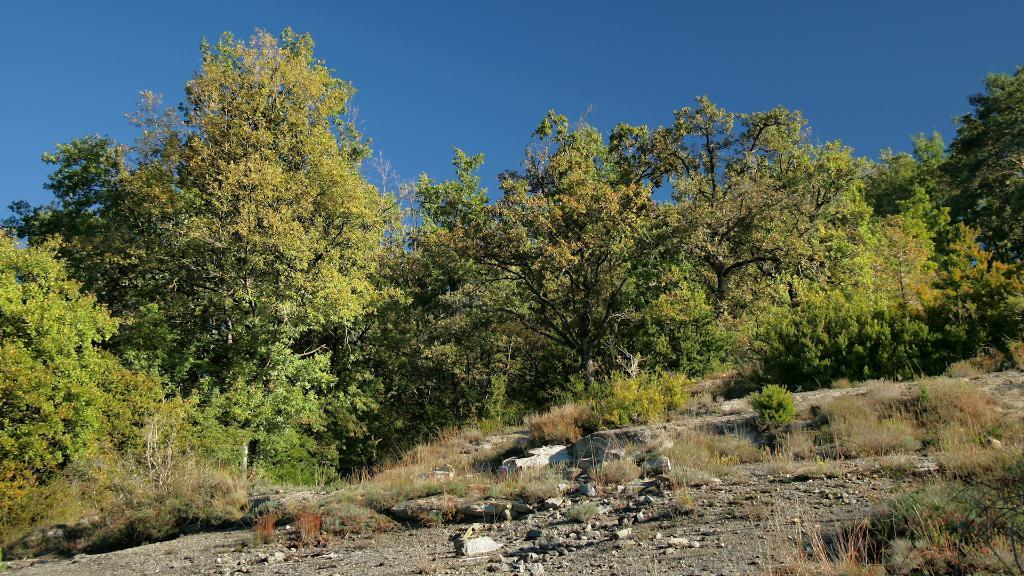What type of natural elements can be seen on the ground in the image? There are rocks on the ground in the image. What type of vegetation is visible in the background of the image? There are trees in the background of the image. What is the color of the sky in the image? The sky is blue in color in the image. Can you tell me how many yams are growing near the rocks in the image? There are no yams present in the image; it features rocks and trees. What type of pipe is visible in the image? There is no pipe present in the image. 